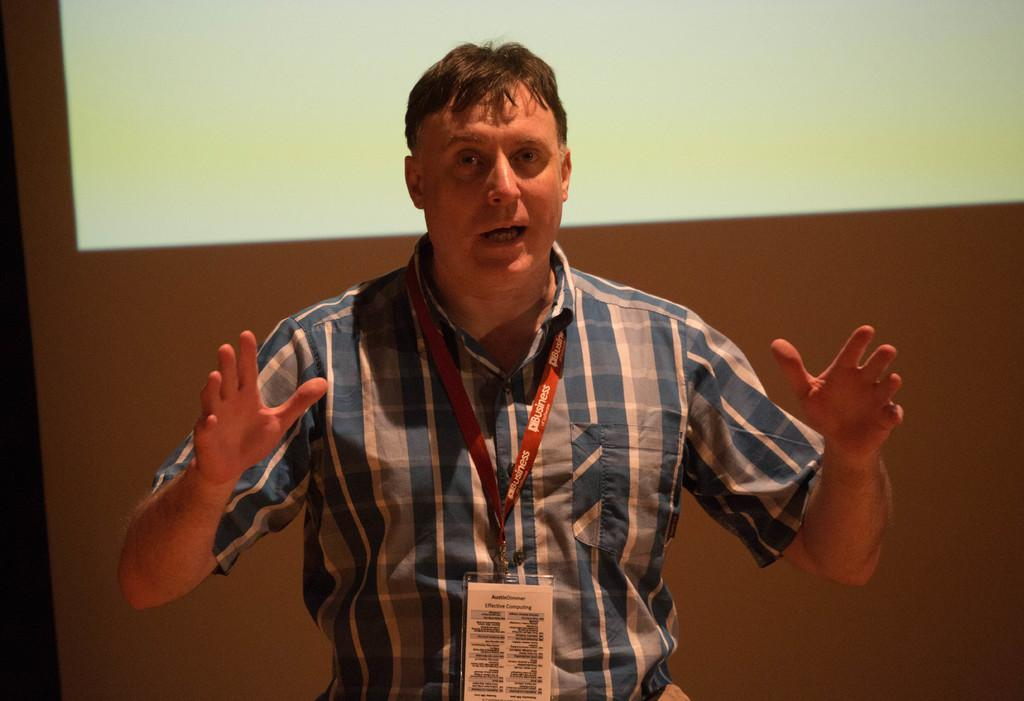Who is present in the image? There is a man in the image. What can be seen on the man? The man has a tag. What is the man doing in the image? The man is explaining something. What is in the background of the image? There is a projector screen in the background of the image. What type of loaf is being used to grade the needle in the image? There is no loaf or needle present in the image; it features a man with a tag who is explaining something. 